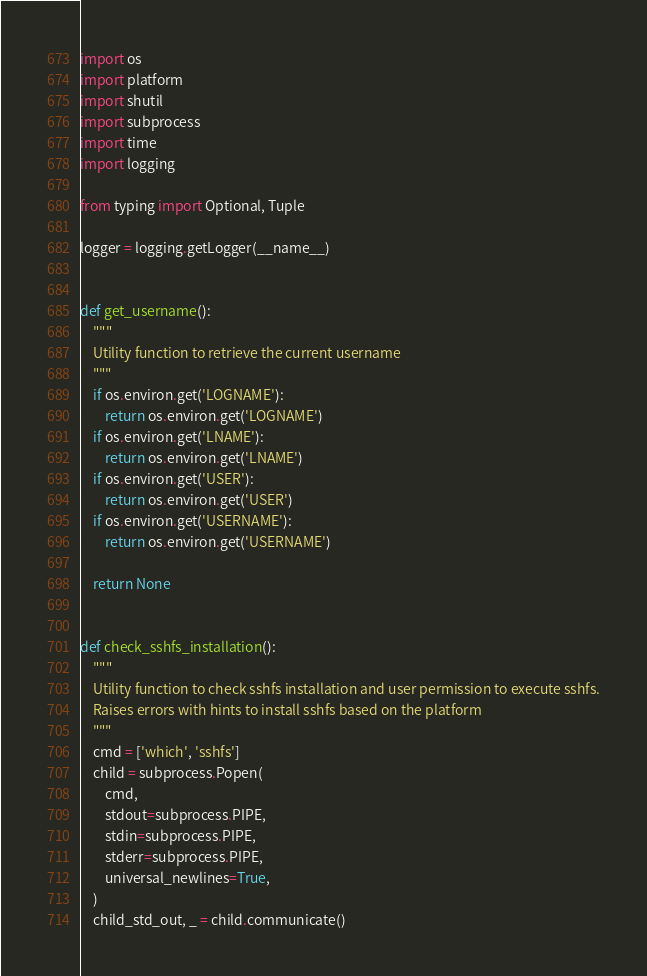Convert code to text. <code><loc_0><loc_0><loc_500><loc_500><_Python_>import os
import platform
import shutil
import subprocess
import time
import logging

from typing import Optional, Tuple

logger = logging.getLogger(__name__)


def get_username():
    """
    Utility function to retrieve the current username
    """
    if os.environ.get('LOGNAME'):
        return os.environ.get('LOGNAME')
    if os.environ.get('LNAME'):
        return os.environ.get('LNAME')
    if os.environ.get('USER'):
        return os.environ.get('USER')
    if os.environ.get('USERNAME'):
        return os.environ.get('USERNAME')

    return None


def check_sshfs_installation():
    """
    Utility function to check sshfs installation and user permission to execute sshfs.
    Raises errors with hints to install sshfs based on the platform
    """
    cmd = ['which', 'sshfs']
    child = subprocess.Popen(
        cmd,
        stdout=subprocess.PIPE,
        stdin=subprocess.PIPE,
        stderr=subprocess.PIPE,
        universal_newlines=True,
    )
    child_std_out, _ = child.communicate()</code> 